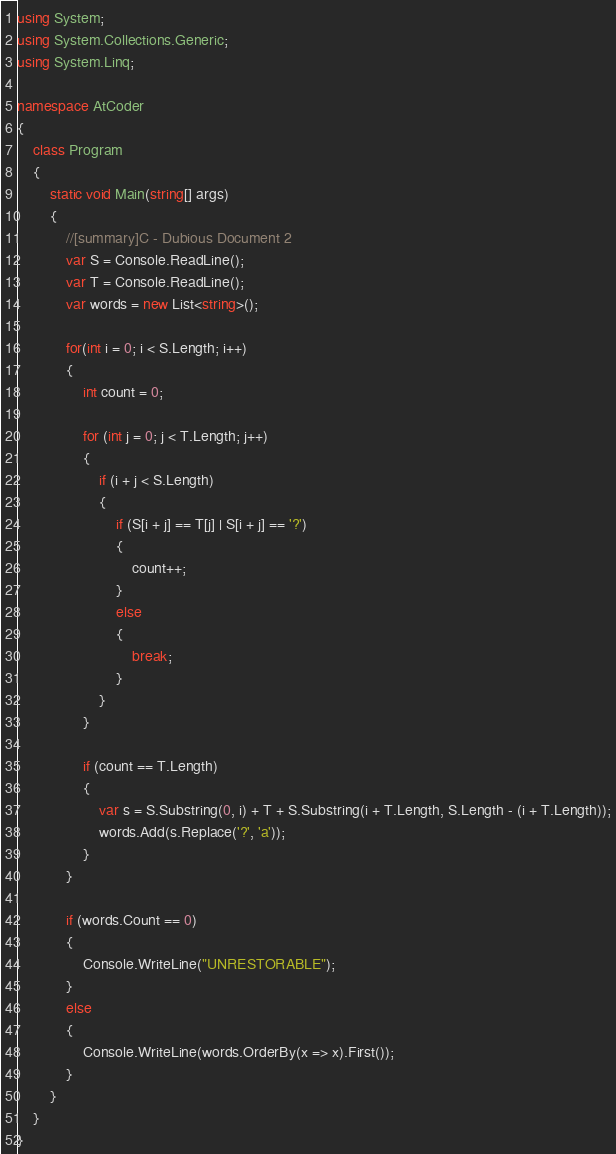Convert code to text. <code><loc_0><loc_0><loc_500><loc_500><_C#_>using System;
using System.Collections.Generic;
using System.Linq;

namespace AtCoder
{
    class Program
    {
        static void Main(string[] args)
        {
            //[summary]C - Dubious Document 2
            var S = Console.ReadLine();
            var T = Console.ReadLine();
            var words = new List<string>();

            for(int i = 0; i < S.Length; i++)
            {
                int count = 0;

                for (int j = 0; j < T.Length; j++)
                {
                    if (i + j < S.Length)
                    {
                        if (S[i + j] == T[j] | S[i + j] == '?')
                        {
                            count++;
                        }
                        else
                        {
                            break;
                        }
                    }                    
                }

                if (count == T.Length)
                {
                    var s = S.Substring(0, i) + T + S.Substring(i + T.Length, S.Length - (i + T.Length));
                    words.Add(s.Replace('?', 'a'));
                }
            }

            if (words.Count == 0)
            {
                Console.WriteLine("UNRESTORABLE");
            }
            else
            {
                Console.WriteLine(words.OrderBy(x => x).First());
            }
        }
    }
}</code> 